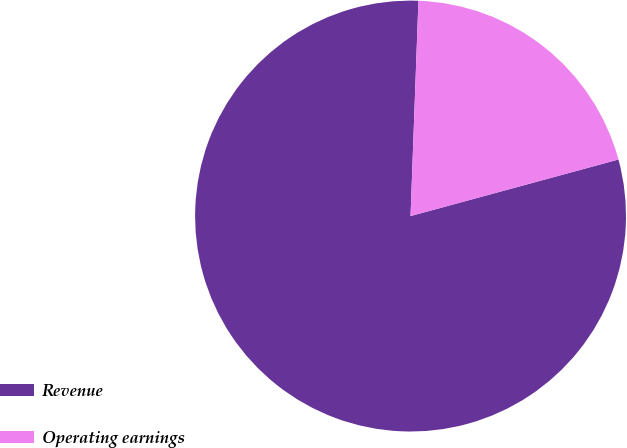Convert chart. <chart><loc_0><loc_0><loc_500><loc_500><pie_chart><fcel>Revenue<fcel>Operating earnings<nl><fcel>79.81%<fcel>20.19%<nl></chart> 